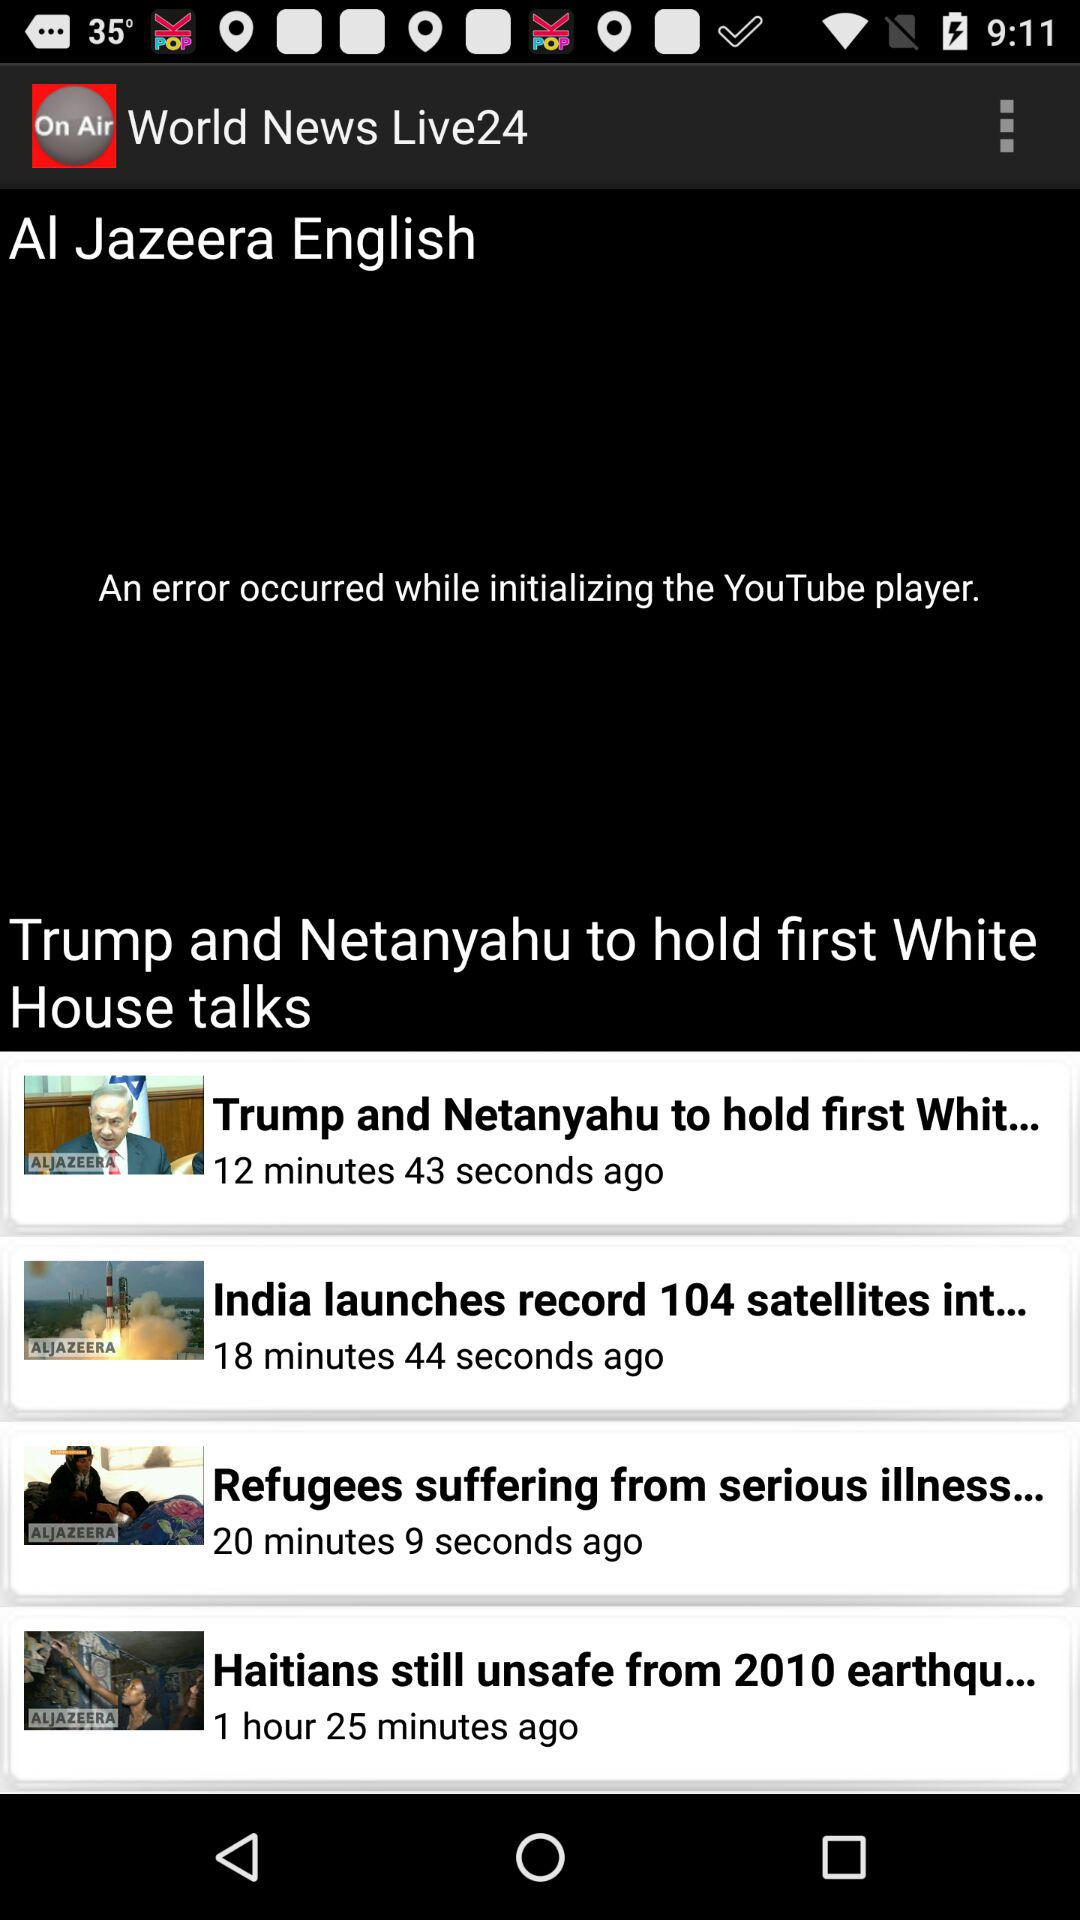How many satellites has India launched? India has launched 104 satellites. 